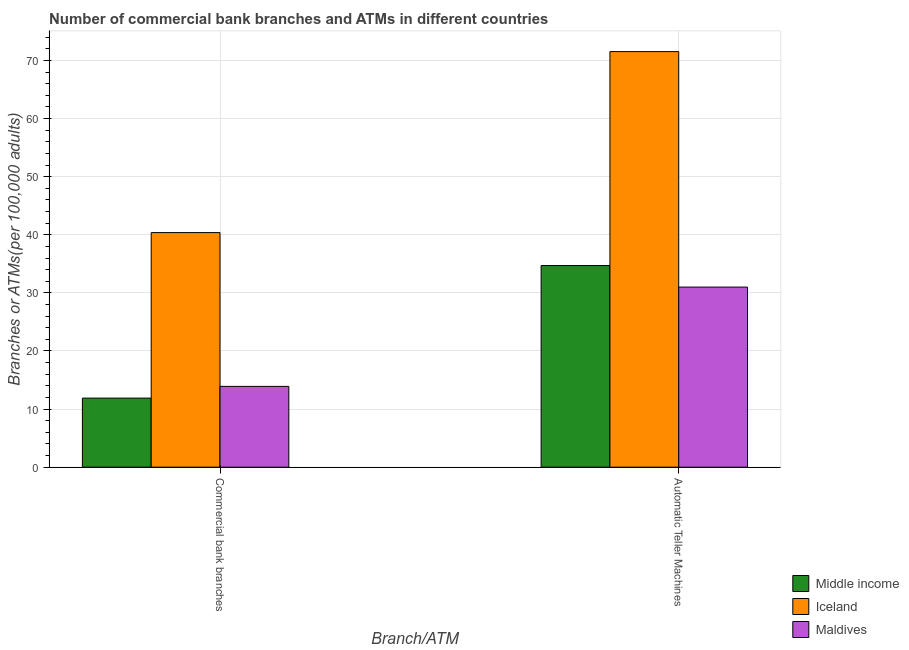How many groups of bars are there?
Offer a terse response. 2. Are the number of bars per tick equal to the number of legend labels?
Offer a terse response. Yes. How many bars are there on the 1st tick from the left?
Your response must be concise. 3. How many bars are there on the 2nd tick from the right?
Give a very brief answer. 3. What is the label of the 2nd group of bars from the left?
Give a very brief answer. Automatic Teller Machines. What is the number of atms in Maldives?
Your answer should be compact. 31. Across all countries, what is the maximum number of atms?
Your response must be concise. 71.53. Across all countries, what is the minimum number of atms?
Offer a terse response. 31. What is the total number of commercal bank branches in the graph?
Your response must be concise. 66.18. What is the difference between the number of atms in Maldives and that in Iceland?
Ensure brevity in your answer.  -40.53. What is the difference between the number of commercal bank branches in Iceland and the number of atms in Maldives?
Make the answer very short. 9.38. What is the average number of atms per country?
Your answer should be compact. 45.75. What is the difference between the number of atms and number of commercal bank branches in Maldives?
Keep it short and to the point. 17.09. In how many countries, is the number of atms greater than 60 ?
Your answer should be compact. 1. What is the ratio of the number of atms in Maldives to that in Iceland?
Provide a succinct answer. 0.43. What does the 1st bar from the right in Automatic Teller Machines represents?
Make the answer very short. Maldives. How many bars are there?
Offer a very short reply. 6. Are all the bars in the graph horizontal?
Give a very brief answer. No. What is the difference between two consecutive major ticks on the Y-axis?
Offer a terse response. 10. Are the values on the major ticks of Y-axis written in scientific E-notation?
Give a very brief answer. No. Where does the legend appear in the graph?
Your response must be concise. Bottom right. How are the legend labels stacked?
Keep it short and to the point. Vertical. What is the title of the graph?
Make the answer very short. Number of commercial bank branches and ATMs in different countries. Does "Panama" appear as one of the legend labels in the graph?
Keep it short and to the point. No. What is the label or title of the X-axis?
Provide a succinct answer. Branch/ATM. What is the label or title of the Y-axis?
Provide a short and direct response. Branches or ATMs(per 100,0 adults). What is the Branches or ATMs(per 100,000 adults) in Middle income in Commercial bank branches?
Your response must be concise. 11.89. What is the Branches or ATMs(per 100,000 adults) in Iceland in Commercial bank branches?
Make the answer very short. 40.38. What is the Branches or ATMs(per 100,000 adults) in Maldives in Commercial bank branches?
Make the answer very short. 13.91. What is the Branches or ATMs(per 100,000 adults) of Middle income in Automatic Teller Machines?
Give a very brief answer. 34.71. What is the Branches or ATMs(per 100,000 adults) of Iceland in Automatic Teller Machines?
Your answer should be compact. 71.53. What is the Branches or ATMs(per 100,000 adults) in Maldives in Automatic Teller Machines?
Offer a very short reply. 31. Across all Branch/ATM, what is the maximum Branches or ATMs(per 100,000 adults) in Middle income?
Make the answer very short. 34.71. Across all Branch/ATM, what is the maximum Branches or ATMs(per 100,000 adults) of Iceland?
Your answer should be very brief. 71.53. Across all Branch/ATM, what is the maximum Branches or ATMs(per 100,000 adults) in Maldives?
Offer a very short reply. 31. Across all Branch/ATM, what is the minimum Branches or ATMs(per 100,000 adults) of Middle income?
Your answer should be very brief. 11.89. Across all Branch/ATM, what is the minimum Branches or ATMs(per 100,000 adults) of Iceland?
Your answer should be very brief. 40.38. Across all Branch/ATM, what is the minimum Branches or ATMs(per 100,000 adults) in Maldives?
Keep it short and to the point. 13.91. What is the total Branches or ATMs(per 100,000 adults) of Middle income in the graph?
Provide a succinct answer. 46.6. What is the total Branches or ATMs(per 100,000 adults) in Iceland in the graph?
Provide a short and direct response. 111.91. What is the total Branches or ATMs(per 100,000 adults) in Maldives in the graph?
Provide a succinct answer. 44.91. What is the difference between the Branches or ATMs(per 100,000 adults) of Middle income in Commercial bank branches and that in Automatic Teller Machines?
Provide a short and direct response. -22.82. What is the difference between the Branches or ATMs(per 100,000 adults) of Iceland in Commercial bank branches and that in Automatic Teller Machines?
Make the answer very short. -31.15. What is the difference between the Branches or ATMs(per 100,000 adults) in Maldives in Commercial bank branches and that in Automatic Teller Machines?
Provide a succinct answer. -17.09. What is the difference between the Branches or ATMs(per 100,000 adults) of Middle income in Commercial bank branches and the Branches or ATMs(per 100,000 adults) of Iceland in Automatic Teller Machines?
Your answer should be compact. -59.64. What is the difference between the Branches or ATMs(per 100,000 adults) in Middle income in Commercial bank branches and the Branches or ATMs(per 100,000 adults) in Maldives in Automatic Teller Machines?
Your response must be concise. -19.11. What is the difference between the Branches or ATMs(per 100,000 adults) of Iceland in Commercial bank branches and the Branches or ATMs(per 100,000 adults) of Maldives in Automatic Teller Machines?
Give a very brief answer. 9.38. What is the average Branches or ATMs(per 100,000 adults) in Middle income per Branch/ATM?
Your answer should be compact. 23.3. What is the average Branches or ATMs(per 100,000 adults) in Iceland per Branch/ATM?
Provide a succinct answer. 55.95. What is the average Branches or ATMs(per 100,000 adults) of Maldives per Branch/ATM?
Ensure brevity in your answer.  22.46. What is the difference between the Branches or ATMs(per 100,000 adults) of Middle income and Branches or ATMs(per 100,000 adults) of Iceland in Commercial bank branches?
Offer a terse response. -28.49. What is the difference between the Branches or ATMs(per 100,000 adults) in Middle income and Branches or ATMs(per 100,000 adults) in Maldives in Commercial bank branches?
Make the answer very short. -2.02. What is the difference between the Branches or ATMs(per 100,000 adults) in Iceland and Branches or ATMs(per 100,000 adults) in Maldives in Commercial bank branches?
Make the answer very short. 26.47. What is the difference between the Branches or ATMs(per 100,000 adults) in Middle income and Branches or ATMs(per 100,000 adults) in Iceland in Automatic Teller Machines?
Offer a terse response. -36.82. What is the difference between the Branches or ATMs(per 100,000 adults) of Middle income and Branches or ATMs(per 100,000 adults) of Maldives in Automatic Teller Machines?
Keep it short and to the point. 3.71. What is the difference between the Branches or ATMs(per 100,000 adults) of Iceland and Branches or ATMs(per 100,000 adults) of Maldives in Automatic Teller Machines?
Offer a terse response. 40.53. What is the ratio of the Branches or ATMs(per 100,000 adults) of Middle income in Commercial bank branches to that in Automatic Teller Machines?
Provide a succinct answer. 0.34. What is the ratio of the Branches or ATMs(per 100,000 adults) of Iceland in Commercial bank branches to that in Automatic Teller Machines?
Offer a very short reply. 0.56. What is the ratio of the Branches or ATMs(per 100,000 adults) of Maldives in Commercial bank branches to that in Automatic Teller Machines?
Offer a terse response. 0.45. What is the difference between the highest and the second highest Branches or ATMs(per 100,000 adults) of Middle income?
Ensure brevity in your answer.  22.82. What is the difference between the highest and the second highest Branches or ATMs(per 100,000 adults) of Iceland?
Give a very brief answer. 31.15. What is the difference between the highest and the second highest Branches or ATMs(per 100,000 adults) in Maldives?
Keep it short and to the point. 17.09. What is the difference between the highest and the lowest Branches or ATMs(per 100,000 adults) of Middle income?
Offer a very short reply. 22.82. What is the difference between the highest and the lowest Branches or ATMs(per 100,000 adults) of Iceland?
Keep it short and to the point. 31.15. What is the difference between the highest and the lowest Branches or ATMs(per 100,000 adults) in Maldives?
Your answer should be very brief. 17.09. 